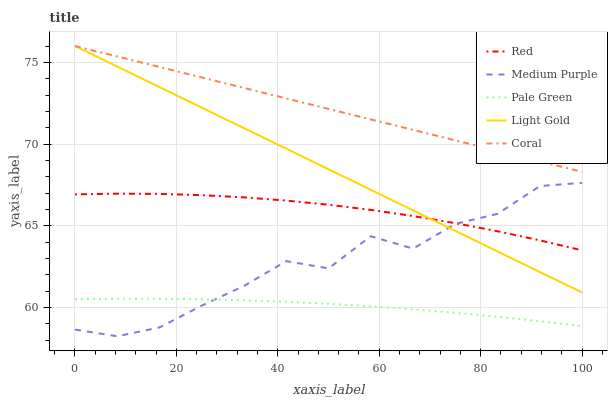Does Pale Green have the minimum area under the curve?
Answer yes or no. Yes. Does Coral have the maximum area under the curve?
Answer yes or no. Yes. Does Coral have the minimum area under the curve?
Answer yes or no. No. Does Pale Green have the maximum area under the curve?
Answer yes or no. No. Is Coral the smoothest?
Answer yes or no. Yes. Is Medium Purple the roughest?
Answer yes or no. Yes. Is Pale Green the smoothest?
Answer yes or no. No. Is Pale Green the roughest?
Answer yes or no. No. Does Medium Purple have the lowest value?
Answer yes or no. Yes. Does Pale Green have the lowest value?
Answer yes or no. No. Does Light Gold have the highest value?
Answer yes or no. Yes. Does Pale Green have the highest value?
Answer yes or no. No. Is Pale Green less than Light Gold?
Answer yes or no. Yes. Is Coral greater than Pale Green?
Answer yes or no. Yes. Does Coral intersect Light Gold?
Answer yes or no. Yes. Is Coral less than Light Gold?
Answer yes or no. No. Is Coral greater than Light Gold?
Answer yes or no. No. Does Pale Green intersect Light Gold?
Answer yes or no. No. 